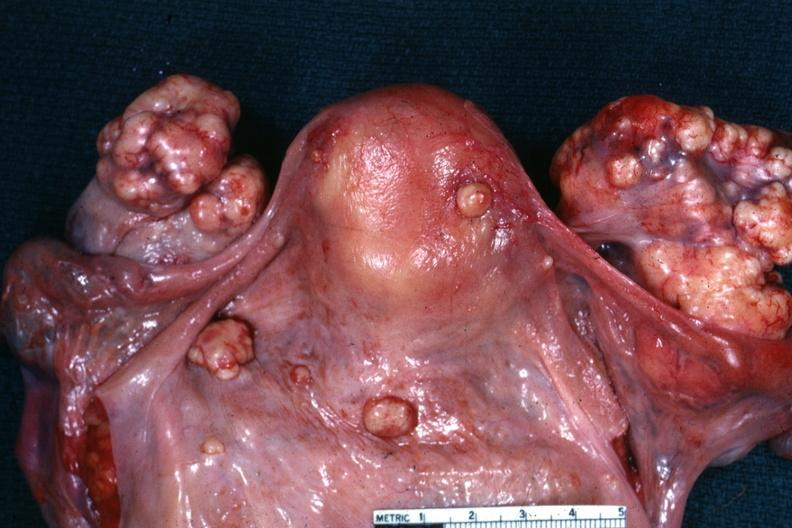what was in the stomach this is true bilateral krukenberg?
Answer the question using a single word or phrase. View of uterus tubes and ovaries showing large nodular metastatic tumor masses on ovaries and peritoneal surface of uterus and douglas pouch outstanding photo primary 